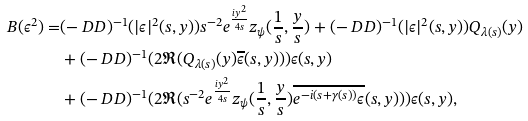<formula> <loc_0><loc_0><loc_500><loc_500>B ( \epsilon ^ { 2 } ) = & ( - \ D D ) ^ { - 1 } ( | \epsilon | ^ { 2 } ( s , y ) ) s ^ { - 2 } e ^ { \frac { i y ^ { 2 } } { 4 s } } z _ { \psi } ( \frac { 1 } { s } , \frac { y } { s } ) + ( - \ D D ) ^ { - 1 } ( | \epsilon | ^ { 2 } ( s , y ) ) Q _ { \lambda ( s ) } ( y ) \\ & + ( - \ D D ) ^ { - 1 } ( 2 \Re ( Q _ { \lambda ( s ) } ( y ) \overline { \epsilon } ( s , y ) ) ) \epsilon ( s , y ) \\ & + ( - \ D D ) ^ { - 1 } ( 2 \Re ( s ^ { - 2 } e ^ { \frac { i y ^ { 2 } } { 4 s } } z _ { \psi } ( \frac { 1 } { s } , \frac { y } { s } ) \overline { e ^ { - i ( s + \gamma ( s ) ) } \epsilon } ( s , y ) ) ) \epsilon ( s , y ) ,</formula> 